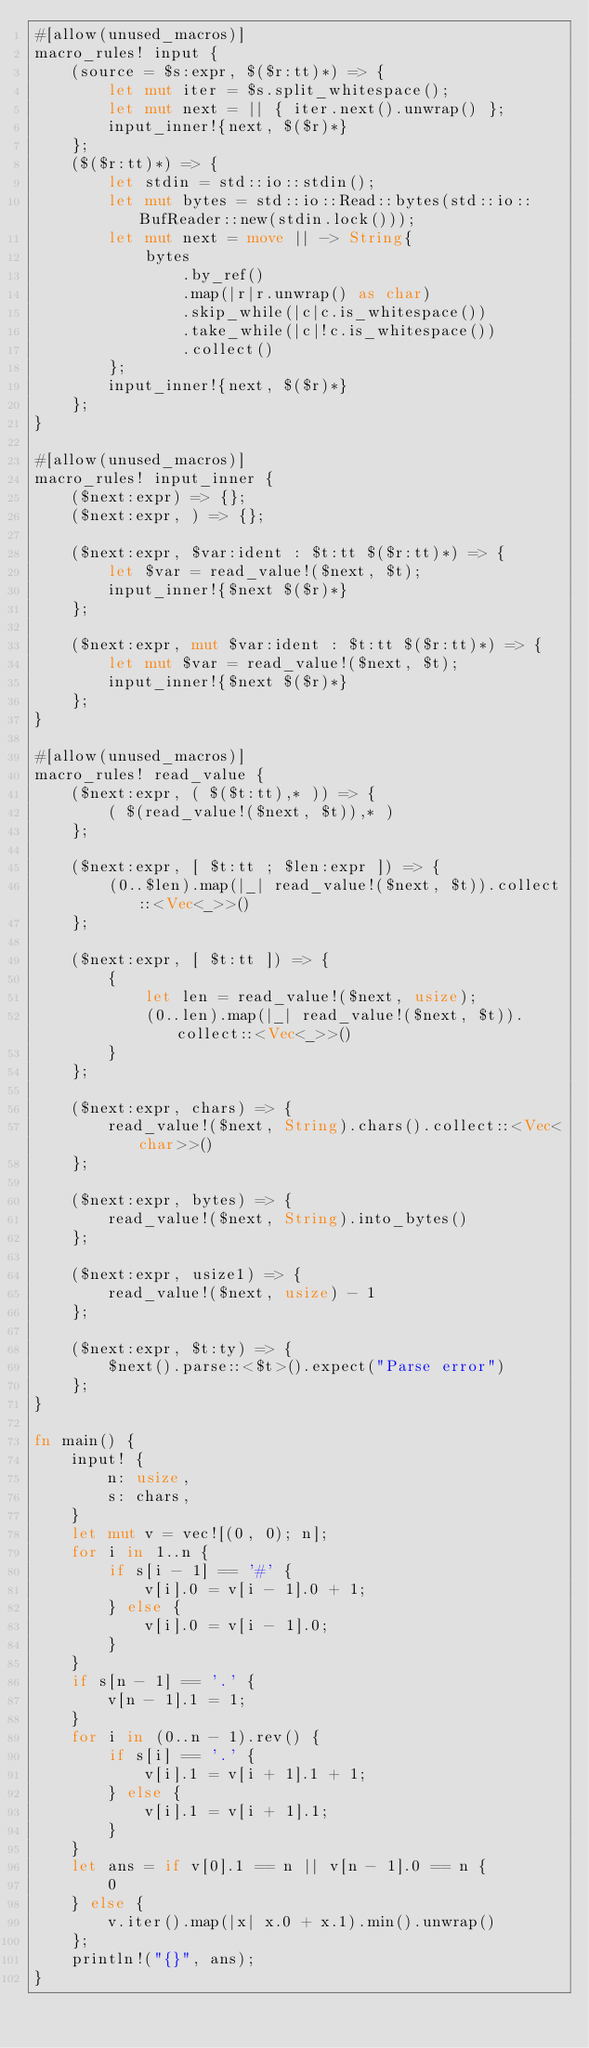<code> <loc_0><loc_0><loc_500><loc_500><_Rust_>#[allow(unused_macros)]
macro_rules! input {
    (source = $s:expr, $($r:tt)*) => {
        let mut iter = $s.split_whitespace();
        let mut next = || { iter.next().unwrap() };
        input_inner!{next, $($r)*}
    };
    ($($r:tt)*) => {
        let stdin = std::io::stdin();
        let mut bytes = std::io::Read::bytes(std::io::BufReader::new(stdin.lock()));
        let mut next = move || -> String{
            bytes
                .by_ref()
                .map(|r|r.unwrap() as char)
                .skip_while(|c|c.is_whitespace())
                .take_while(|c|!c.is_whitespace())
                .collect()
        };
        input_inner!{next, $($r)*}
    };
}

#[allow(unused_macros)]
macro_rules! input_inner {
    ($next:expr) => {};
    ($next:expr, ) => {};

    ($next:expr, $var:ident : $t:tt $($r:tt)*) => {
        let $var = read_value!($next, $t);
        input_inner!{$next $($r)*}
    };

    ($next:expr, mut $var:ident : $t:tt $($r:tt)*) => {
        let mut $var = read_value!($next, $t);
        input_inner!{$next $($r)*}
    };
}

#[allow(unused_macros)]
macro_rules! read_value {
    ($next:expr, ( $($t:tt),* )) => {
        ( $(read_value!($next, $t)),* )
    };

    ($next:expr, [ $t:tt ; $len:expr ]) => {
        (0..$len).map(|_| read_value!($next, $t)).collect::<Vec<_>>()
    };

    ($next:expr, [ $t:tt ]) => {
        {
            let len = read_value!($next, usize);
            (0..len).map(|_| read_value!($next, $t)).collect::<Vec<_>>()
        }
    };

    ($next:expr, chars) => {
        read_value!($next, String).chars().collect::<Vec<char>>()
    };

    ($next:expr, bytes) => {
        read_value!($next, String).into_bytes()
    };

    ($next:expr, usize1) => {
        read_value!($next, usize) - 1
    };

    ($next:expr, $t:ty) => {
        $next().parse::<$t>().expect("Parse error")
    };
}

fn main() {
    input! {
        n: usize,
        s: chars,
    }
    let mut v = vec![(0, 0); n];
    for i in 1..n {
        if s[i - 1] == '#' {
            v[i].0 = v[i - 1].0 + 1;
        } else {
            v[i].0 = v[i - 1].0;
        }
    }
    if s[n - 1] == '.' {
        v[n - 1].1 = 1;
    }
    for i in (0..n - 1).rev() {
        if s[i] == '.' {
            v[i].1 = v[i + 1].1 + 1;
        } else {
            v[i].1 = v[i + 1].1;
        }
    }
    let ans = if v[0].1 == n || v[n - 1].0 == n {
        0
    } else {
        v.iter().map(|x| x.0 + x.1).min().unwrap()
    };
    println!("{}", ans);
}
</code> 